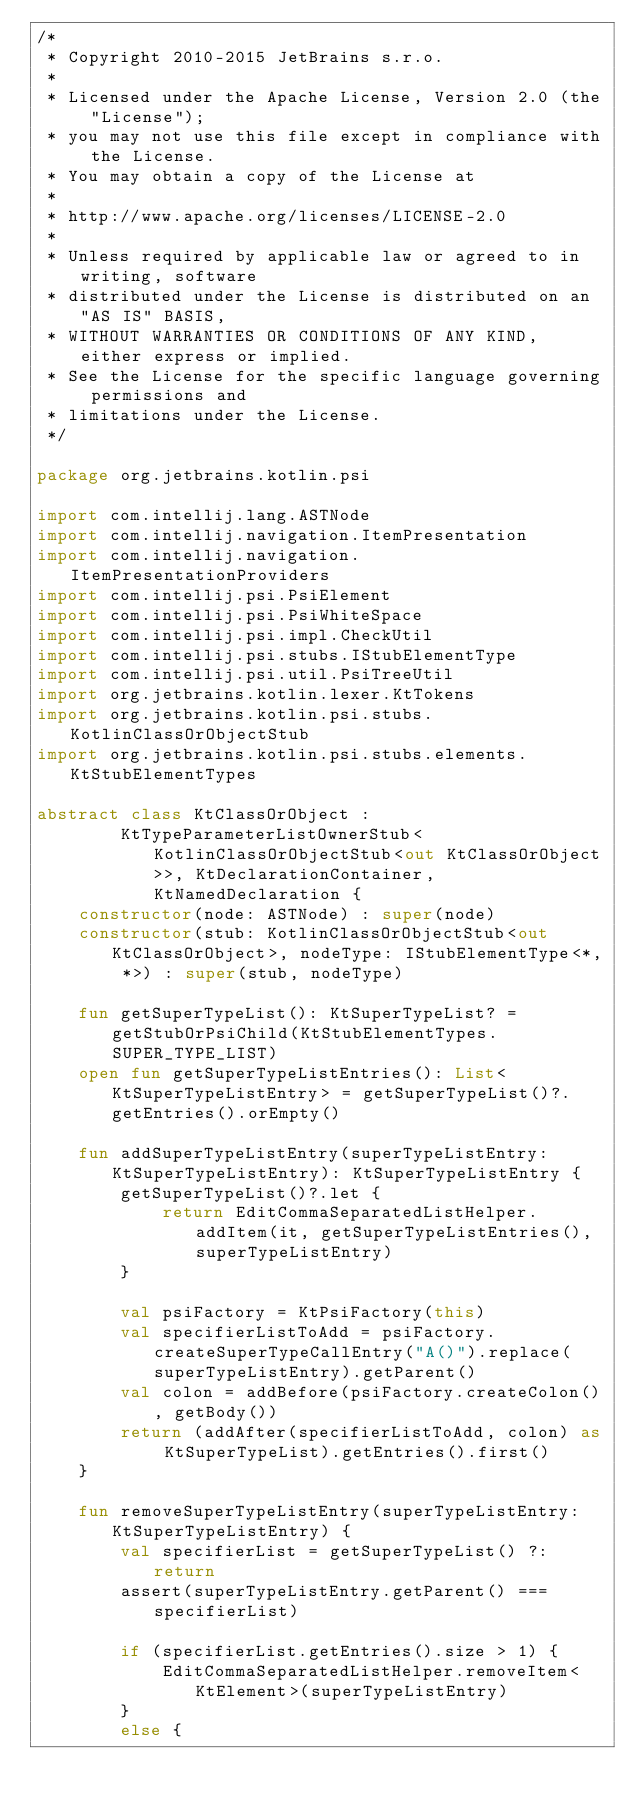Convert code to text. <code><loc_0><loc_0><loc_500><loc_500><_Kotlin_>/*
 * Copyright 2010-2015 JetBrains s.r.o.
 *
 * Licensed under the Apache License, Version 2.0 (the "License");
 * you may not use this file except in compliance with the License.
 * You may obtain a copy of the License at
 *
 * http://www.apache.org/licenses/LICENSE-2.0
 *
 * Unless required by applicable law or agreed to in writing, software
 * distributed under the License is distributed on an "AS IS" BASIS,
 * WITHOUT WARRANTIES OR CONDITIONS OF ANY KIND, either express or implied.
 * See the License for the specific language governing permissions and
 * limitations under the License.
 */

package org.jetbrains.kotlin.psi

import com.intellij.lang.ASTNode
import com.intellij.navigation.ItemPresentation
import com.intellij.navigation.ItemPresentationProviders
import com.intellij.psi.PsiElement
import com.intellij.psi.PsiWhiteSpace
import com.intellij.psi.impl.CheckUtil
import com.intellij.psi.stubs.IStubElementType
import com.intellij.psi.util.PsiTreeUtil
import org.jetbrains.kotlin.lexer.KtTokens
import org.jetbrains.kotlin.psi.stubs.KotlinClassOrObjectStub
import org.jetbrains.kotlin.psi.stubs.elements.KtStubElementTypes

abstract class KtClassOrObject :
        KtTypeParameterListOwnerStub<KotlinClassOrObjectStub<out KtClassOrObject>>, KtDeclarationContainer, KtNamedDeclaration {
    constructor(node: ASTNode) : super(node)
    constructor(stub: KotlinClassOrObjectStub<out KtClassOrObject>, nodeType: IStubElementType<*, *>) : super(stub, nodeType)

    fun getSuperTypeList(): KtSuperTypeList? = getStubOrPsiChild(KtStubElementTypes.SUPER_TYPE_LIST)
    open fun getSuperTypeListEntries(): List<KtSuperTypeListEntry> = getSuperTypeList()?.getEntries().orEmpty()

    fun addSuperTypeListEntry(superTypeListEntry: KtSuperTypeListEntry): KtSuperTypeListEntry {
        getSuperTypeList()?.let {
            return EditCommaSeparatedListHelper.addItem(it, getSuperTypeListEntries(), superTypeListEntry)
        }

        val psiFactory = KtPsiFactory(this)
        val specifierListToAdd = psiFactory.createSuperTypeCallEntry("A()").replace(superTypeListEntry).getParent()
        val colon = addBefore(psiFactory.createColon(), getBody())
        return (addAfter(specifierListToAdd, colon) as KtSuperTypeList).getEntries().first()
    }

    fun removeSuperTypeListEntry(superTypeListEntry: KtSuperTypeListEntry) {
        val specifierList = getSuperTypeList() ?: return
        assert(superTypeListEntry.getParent() === specifierList)

        if (specifierList.getEntries().size > 1) {
            EditCommaSeparatedListHelper.removeItem<KtElement>(superTypeListEntry)
        }
        else {</code> 